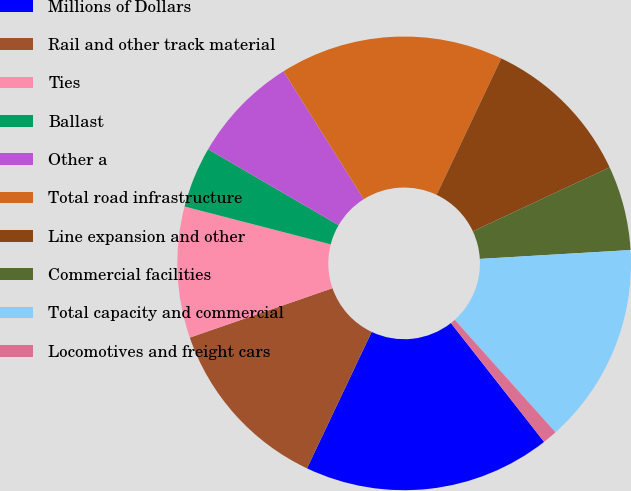Convert chart to OTSL. <chart><loc_0><loc_0><loc_500><loc_500><pie_chart><fcel>Millions of Dollars<fcel>Rail and other track material<fcel>Ties<fcel>Ballast<fcel>Other a<fcel>Total road infrastructure<fcel>Line expansion and other<fcel>Commercial facilities<fcel>Total capacity and commercial<fcel>Locomotives and freight cars<nl><fcel>17.63%<fcel>12.65%<fcel>9.34%<fcel>4.36%<fcel>7.68%<fcel>15.97%<fcel>11.0%<fcel>6.02%<fcel>14.31%<fcel>1.04%<nl></chart> 